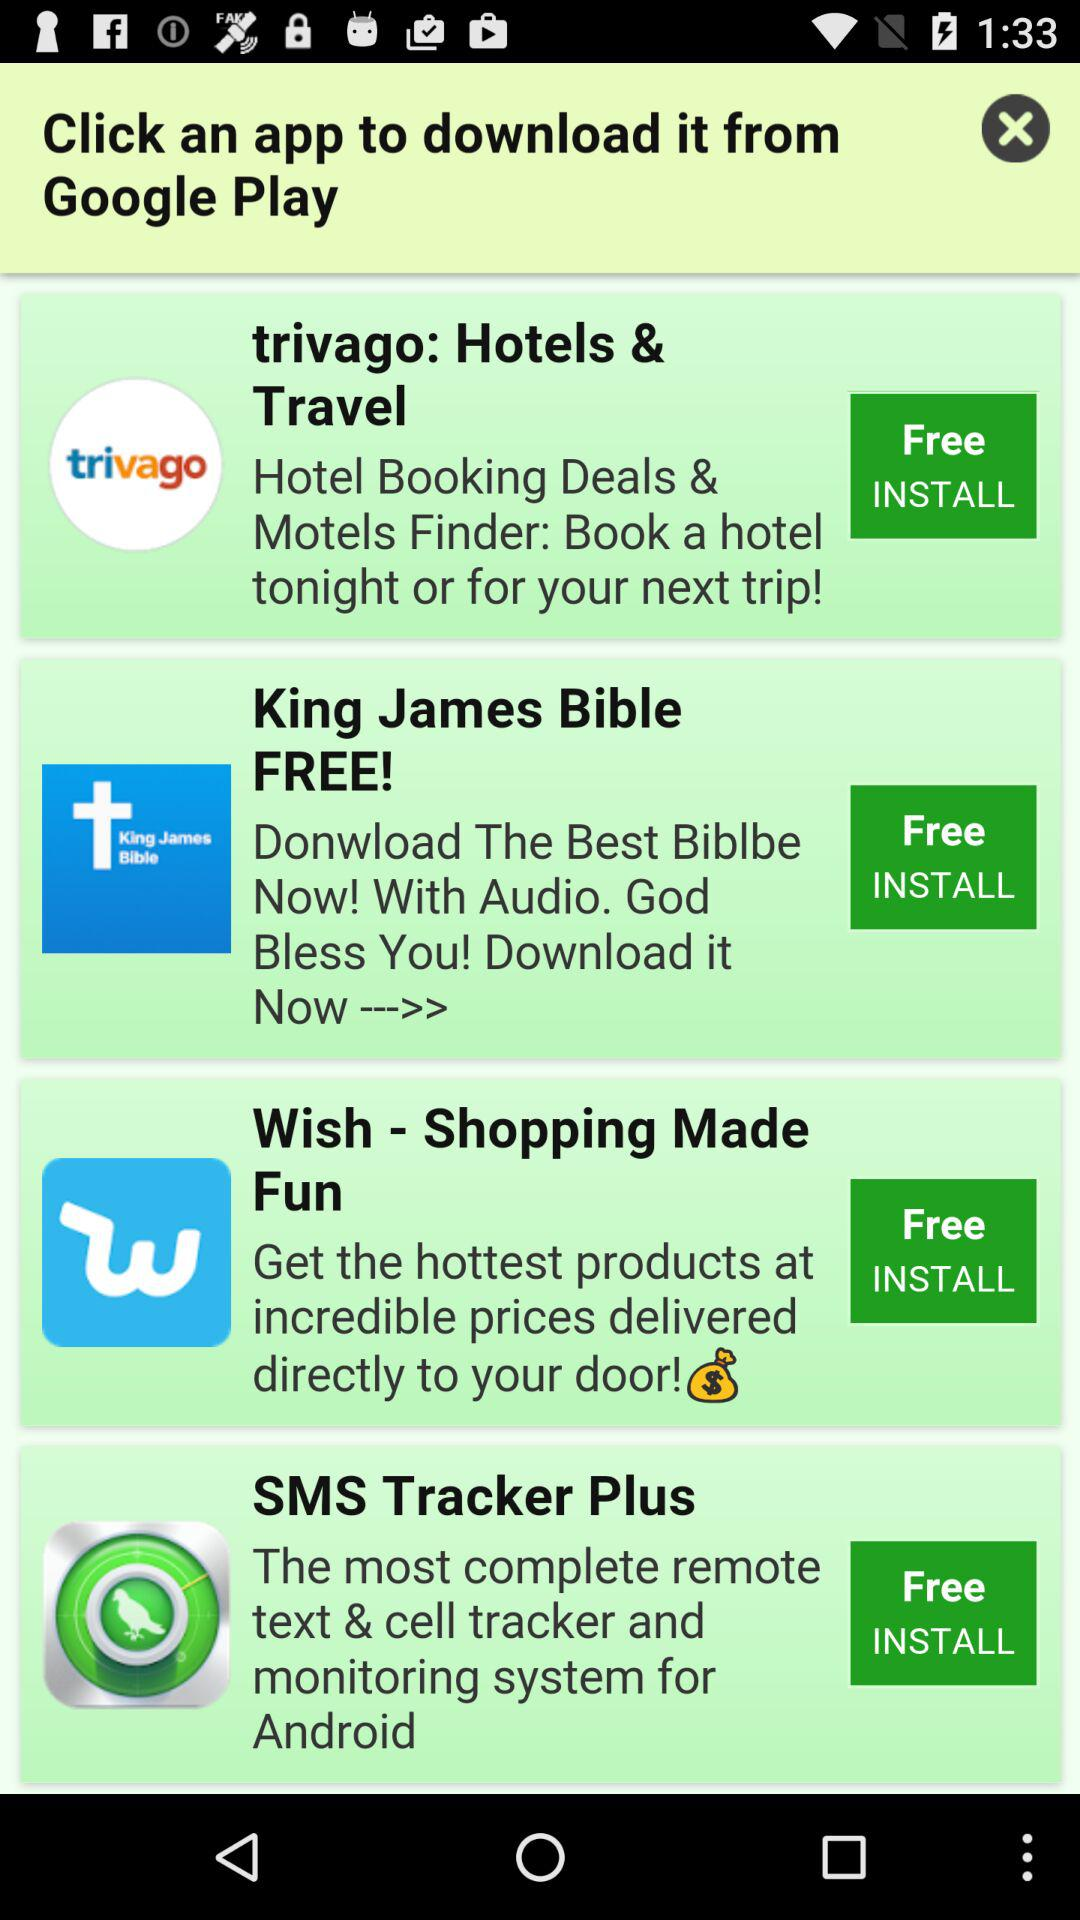Is SMS tracker plus free or paid? The SMS tracker plus is free. 